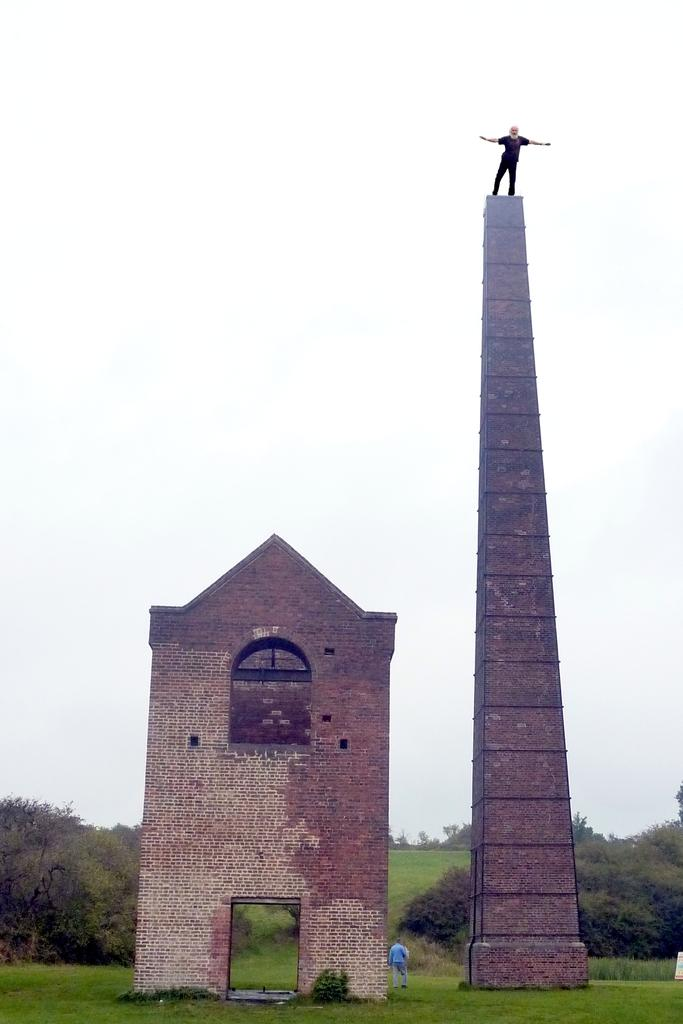What is the person in the image doing? There is a person on a tower in the image. What architectural feature can be seen in the image? There is a wall with an arch in the image. What type of vegetation is visible in the image? There is grass visible in the image. What else can be seen in the image besides the tower and wall? There are trees in the image. What is visible in the background of the image? The sky is visible in the image. What type of hot meal is being prepared in the image? There is no indication of a meal being prepared in the image; it primarily features a person on a tower and various architectural and natural elements. 